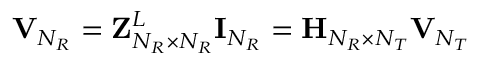<formula> <loc_0><loc_0><loc_500><loc_500>{ V } _ { N _ { R } } = { Z } _ { N _ { R } \times N _ { R } } ^ { L } { I } _ { N _ { R } } = { H } _ { N _ { R } \times N _ { T } } { V } _ { N _ { T } }</formula> 